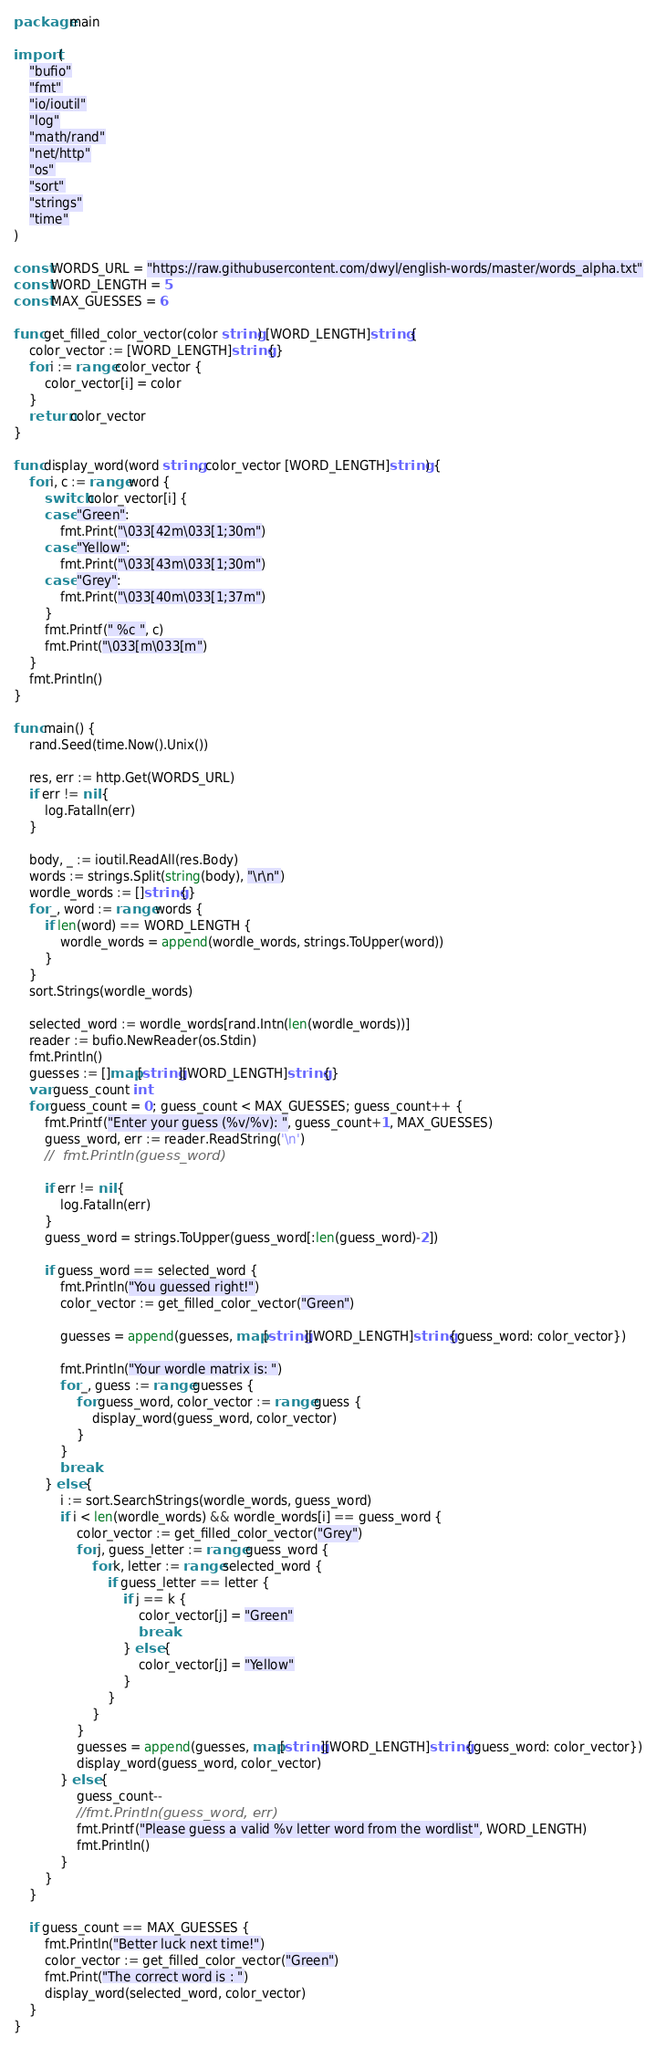<code> <loc_0><loc_0><loc_500><loc_500><_Go_>package main

import (
	"bufio"
	"fmt"
	"io/ioutil"
	"log"
	"math/rand"
	"net/http"
	"os"
	"sort"
	"strings"
	"time"
)

const WORDS_URL = "https://raw.githubusercontent.com/dwyl/english-words/master/words_alpha.txt"
const WORD_LENGTH = 5
const MAX_GUESSES = 6

func get_filled_color_vector(color string) [WORD_LENGTH]string {
	color_vector := [WORD_LENGTH]string{}
	for i := range color_vector {
		color_vector[i] = color
	}
	return color_vector
}

func display_word(word string, color_vector [WORD_LENGTH]string) {
	for i, c := range word {
		switch color_vector[i] {
		case "Green":
			fmt.Print("\033[42m\033[1;30m")
		case "Yellow":
			fmt.Print("\033[43m\033[1;30m")
		case "Grey":
			fmt.Print("\033[40m\033[1;37m")
		}
		fmt.Printf(" %c ", c)
		fmt.Print("\033[m\033[m")
	}
	fmt.Println()
}

func main() {
	rand.Seed(time.Now().Unix())

	res, err := http.Get(WORDS_URL)
	if err != nil {
		log.Fatalln(err)
	}

	body, _ := ioutil.ReadAll(res.Body)
	words := strings.Split(string(body), "\r\n")
	wordle_words := []string{}
	for _, word := range words {
		if len(word) == WORD_LENGTH {
			wordle_words = append(wordle_words, strings.ToUpper(word))
		}
	}
	sort.Strings(wordle_words)

	selected_word := wordle_words[rand.Intn(len(wordle_words))]
	reader := bufio.NewReader(os.Stdin)
	fmt.Println()
	guesses := []map[string][WORD_LENGTH]string{}
	var guess_count int
	for guess_count = 0; guess_count < MAX_GUESSES; guess_count++ {
		fmt.Printf("Enter your guess (%v/%v): ", guess_count+1, MAX_GUESSES)
		guess_word, err := reader.ReadString('\n')
		//	fmt.Println(guess_word)

		if err != nil {
			log.Fatalln(err)
		}
		guess_word = strings.ToUpper(guess_word[:len(guess_word)-2])

		if guess_word == selected_word {
			fmt.Println("You guessed right!")
			color_vector := get_filled_color_vector("Green")

			guesses = append(guesses, map[string][WORD_LENGTH]string{guess_word: color_vector})

			fmt.Println("Your wordle matrix is: ")
			for _, guess := range guesses {
				for guess_word, color_vector := range guess {
					display_word(guess_word, color_vector)
				}
			}
			break
		} else {
			i := sort.SearchStrings(wordle_words, guess_word)
			if i < len(wordle_words) && wordle_words[i] == guess_word {
				color_vector := get_filled_color_vector("Grey")
				for j, guess_letter := range guess_word {
					for k, letter := range selected_word {
						if guess_letter == letter {
							if j == k {
								color_vector[j] = "Green"
								break
							} else {
								color_vector[j] = "Yellow"
							}
						}
					}
				}
				guesses = append(guesses, map[string][WORD_LENGTH]string{guess_word: color_vector})
				display_word(guess_word, color_vector)
			} else {
				guess_count--
				//fmt.Println(guess_word, err)
				fmt.Printf("Please guess a valid %v letter word from the wordlist", WORD_LENGTH)
				fmt.Println()
			}
		}
	}

	if guess_count == MAX_GUESSES {
		fmt.Println("Better luck next time!")
		color_vector := get_filled_color_vector("Green")
		fmt.Print("The correct word is : ")
		display_word(selected_word, color_vector)
	}
}
</code> 